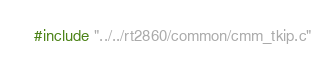<code> <loc_0><loc_0><loc_500><loc_500><_C_>#include "../../rt2860/common/cmm_tkip.c"
</code> 